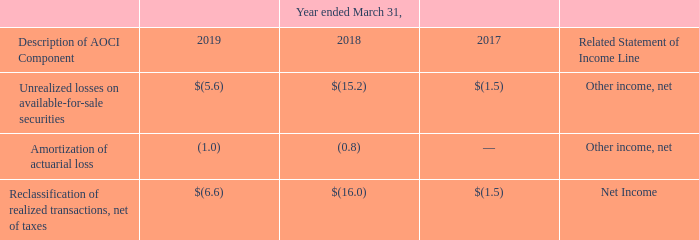Accumulated Other Comprehensive Income
The table below details where reclassifications of realized transactions out of AOCI are recorded on the consolidated statements of income (amounts in millions).
Which years does the table provide information for reclassifications of realized transactions out of AOCI are recorded on the consolidated statements of income? 2019, 2018, 2017. What were the Unrealized losses on available-for-sale securities in 2017?
Answer scale should be: million. (1.5). What was the Amortization of actuarial loss in 2019?
Answer scale should be: million. (1.0). What was the change in the Amortization of actuarial loss between 2018 and 2019?
Answer scale should be: million. -1.0-(-0.8)
Answer: -0.2. What was the change in the Unrealized losses on available-for-sale securities between 2017 and 2018?
Answer scale should be: million. -15.2-(-1.5)
Answer: -13.7. What was the percentage change in the Reclassification of realized transactions, net of taxes between 2018 and 2019?
Answer scale should be: percent. (-6.6-(-16.0))/-16.0
Answer: -58.75. 